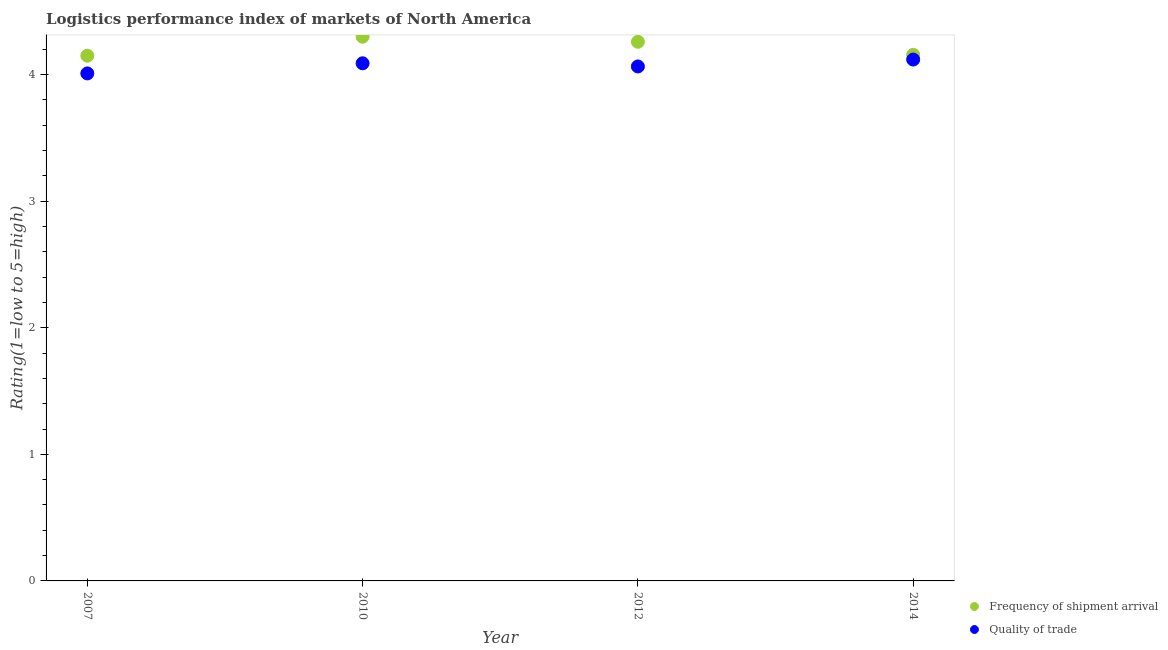How many different coloured dotlines are there?
Offer a terse response. 2. Is the number of dotlines equal to the number of legend labels?
Your answer should be compact. Yes. What is the lpi quality of trade in 2010?
Give a very brief answer. 4.09. Across all years, what is the maximum lpi of frequency of shipment arrival?
Ensure brevity in your answer.  4.3. Across all years, what is the minimum lpi of frequency of shipment arrival?
Ensure brevity in your answer.  4.15. What is the total lpi of frequency of shipment arrival in the graph?
Offer a very short reply. 16.87. What is the difference between the lpi of frequency of shipment arrival in 2007 and that in 2012?
Keep it short and to the point. -0.11. What is the difference between the lpi of frequency of shipment arrival in 2010 and the lpi quality of trade in 2014?
Offer a terse response. 0.18. What is the average lpi of frequency of shipment arrival per year?
Make the answer very short. 4.22. In the year 2012, what is the difference between the lpi quality of trade and lpi of frequency of shipment arrival?
Provide a succinct answer. -0.19. In how many years, is the lpi of frequency of shipment arrival greater than 1.2?
Make the answer very short. 4. What is the ratio of the lpi of frequency of shipment arrival in 2010 to that in 2014?
Provide a succinct answer. 1.03. Is the lpi of frequency of shipment arrival in 2007 less than that in 2012?
Keep it short and to the point. Yes. Is the difference between the lpi of frequency of shipment arrival in 2007 and 2012 greater than the difference between the lpi quality of trade in 2007 and 2012?
Your answer should be very brief. No. What is the difference between the highest and the second highest lpi of frequency of shipment arrival?
Offer a terse response. 0.04. What is the difference between the highest and the lowest lpi quality of trade?
Offer a terse response. 0.11. Is the sum of the lpi of frequency of shipment arrival in 2012 and 2014 greater than the maximum lpi quality of trade across all years?
Your answer should be very brief. Yes. How many dotlines are there?
Your answer should be very brief. 2. How many years are there in the graph?
Provide a short and direct response. 4. What is the difference between two consecutive major ticks on the Y-axis?
Your response must be concise. 1. Are the values on the major ticks of Y-axis written in scientific E-notation?
Provide a short and direct response. No. Does the graph contain any zero values?
Your answer should be compact. No. Where does the legend appear in the graph?
Ensure brevity in your answer.  Bottom right. How are the legend labels stacked?
Make the answer very short. Vertical. What is the title of the graph?
Make the answer very short. Logistics performance index of markets of North America. What is the label or title of the Y-axis?
Give a very brief answer. Rating(1=low to 5=high). What is the Rating(1=low to 5=high) in Frequency of shipment arrival in 2007?
Offer a terse response. 4.15. What is the Rating(1=low to 5=high) of Quality of trade in 2007?
Your answer should be very brief. 4.01. What is the Rating(1=low to 5=high) of Quality of trade in 2010?
Your answer should be very brief. 4.09. What is the Rating(1=low to 5=high) of Frequency of shipment arrival in 2012?
Your response must be concise. 4.26. What is the Rating(1=low to 5=high) of Quality of trade in 2012?
Your answer should be compact. 4.07. What is the Rating(1=low to 5=high) of Frequency of shipment arrival in 2014?
Ensure brevity in your answer.  4.16. What is the Rating(1=low to 5=high) of Quality of trade in 2014?
Keep it short and to the point. 4.12. Across all years, what is the maximum Rating(1=low to 5=high) of Frequency of shipment arrival?
Your answer should be compact. 4.3. Across all years, what is the maximum Rating(1=low to 5=high) in Quality of trade?
Your response must be concise. 4.12. Across all years, what is the minimum Rating(1=low to 5=high) of Frequency of shipment arrival?
Provide a short and direct response. 4.15. Across all years, what is the minimum Rating(1=low to 5=high) of Quality of trade?
Provide a succinct answer. 4.01. What is the total Rating(1=low to 5=high) of Frequency of shipment arrival in the graph?
Keep it short and to the point. 16.87. What is the total Rating(1=low to 5=high) in Quality of trade in the graph?
Ensure brevity in your answer.  16.28. What is the difference between the Rating(1=low to 5=high) of Quality of trade in 2007 and that in 2010?
Give a very brief answer. -0.08. What is the difference between the Rating(1=low to 5=high) of Frequency of shipment arrival in 2007 and that in 2012?
Offer a terse response. -0.11. What is the difference between the Rating(1=low to 5=high) of Quality of trade in 2007 and that in 2012?
Provide a short and direct response. -0.06. What is the difference between the Rating(1=low to 5=high) of Frequency of shipment arrival in 2007 and that in 2014?
Offer a very short reply. -0.01. What is the difference between the Rating(1=low to 5=high) of Quality of trade in 2007 and that in 2014?
Your answer should be very brief. -0.11. What is the difference between the Rating(1=low to 5=high) of Quality of trade in 2010 and that in 2012?
Provide a succinct answer. 0.03. What is the difference between the Rating(1=low to 5=high) in Frequency of shipment arrival in 2010 and that in 2014?
Make the answer very short. 0.14. What is the difference between the Rating(1=low to 5=high) of Quality of trade in 2010 and that in 2014?
Make the answer very short. -0.03. What is the difference between the Rating(1=low to 5=high) in Frequency of shipment arrival in 2012 and that in 2014?
Give a very brief answer. 0.1. What is the difference between the Rating(1=low to 5=high) of Quality of trade in 2012 and that in 2014?
Ensure brevity in your answer.  -0.05. What is the difference between the Rating(1=low to 5=high) in Frequency of shipment arrival in 2007 and the Rating(1=low to 5=high) in Quality of trade in 2010?
Give a very brief answer. 0.06. What is the difference between the Rating(1=low to 5=high) of Frequency of shipment arrival in 2007 and the Rating(1=low to 5=high) of Quality of trade in 2012?
Make the answer very short. 0.09. What is the difference between the Rating(1=low to 5=high) in Frequency of shipment arrival in 2007 and the Rating(1=low to 5=high) in Quality of trade in 2014?
Your response must be concise. 0.03. What is the difference between the Rating(1=low to 5=high) in Frequency of shipment arrival in 2010 and the Rating(1=low to 5=high) in Quality of trade in 2012?
Offer a very short reply. 0.23. What is the difference between the Rating(1=low to 5=high) of Frequency of shipment arrival in 2010 and the Rating(1=low to 5=high) of Quality of trade in 2014?
Your answer should be compact. 0.18. What is the difference between the Rating(1=low to 5=high) of Frequency of shipment arrival in 2012 and the Rating(1=low to 5=high) of Quality of trade in 2014?
Your answer should be compact. 0.14. What is the average Rating(1=low to 5=high) in Frequency of shipment arrival per year?
Keep it short and to the point. 4.22. What is the average Rating(1=low to 5=high) in Quality of trade per year?
Keep it short and to the point. 4.07. In the year 2007, what is the difference between the Rating(1=low to 5=high) in Frequency of shipment arrival and Rating(1=low to 5=high) in Quality of trade?
Keep it short and to the point. 0.14. In the year 2010, what is the difference between the Rating(1=low to 5=high) in Frequency of shipment arrival and Rating(1=low to 5=high) in Quality of trade?
Your answer should be very brief. 0.21. In the year 2012, what is the difference between the Rating(1=low to 5=high) of Frequency of shipment arrival and Rating(1=low to 5=high) of Quality of trade?
Your answer should be very brief. 0.2. In the year 2014, what is the difference between the Rating(1=low to 5=high) of Frequency of shipment arrival and Rating(1=low to 5=high) of Quality of trade?
Give a very brief answer. 0.04. What is the ratio of the Rating(1=low to 5=high) of Frequency of shipment arrival in 2007 to that in 2010?
Keep it short and to the point. 0.97. What is the ratio of the Rating(1=low to 5=high) of Quality of trade in 2007 to that in 2010?
Provide a short and direct response. 0.98. What is the ratio of the Rating(1=low to 5=high) of Frequency of shipment arrival in 2007 to that in 2012?
Give a very brief answer. 0.97. What is the ratio of the Rating(1=low to 5=high) of Quality of trade in 2007 to that in 2012?
Keep it short and to the point. 0.99. What is the ratio of the Rating(1=low to 5=high) in Frequency of shipment arrival in 2007 to that in 2014?
Provide a succinct answer. 1. What is the ratio of the Rating(1=low to 5=high) in Quality of trade in 2007 to that in 2014?
Offer a terse response. 0.97. What is the ratio of the Rating(1=low to 5=high) of Frequency of shipment arrival in 2010 to that in 2012?
Ensure brevity in your answer.  1.01. What is the ratio of the Rating(1=low to 5=high) in Frequency of shipment arrival in 2010 to that in 2014?
Your answer should be very brief. 1.03. What is the ratio of the Rating(1=low to 5=high) in Quality of trade in 2010 to that in 2014?
Your answer should be very brief. 0.99. What is the ratio of the Rating(1=low to 5=high) of Frequency of shipment arrival in 2012 to that in 2014?
Give a very brief answer. 1.02. What is the ratio of the Rating(1=low to 5=high) in Quality of trade in 2012 to that in 2014?
Keep it short and to the point. 0.99. What is the difference between the highest and the second highest Rating(1=low to 5=high) of Frequency of shipment arrival?
Keep it short and to the point. 0.04. What is the difference between the highest and the second highest Rating(1=low to 5=high) in Quality of trade?
Your response must be concise. 0.03. What is the difference between the highest and the lowest Rating(1=low to 5=high) of Frequency of shipment arrival?
Make the answer very short. 0.15. What is the difference between the highest and the lowest Rating(1=low to 5=high) in Quality of trade?
Your response must be concise. 0.11. 